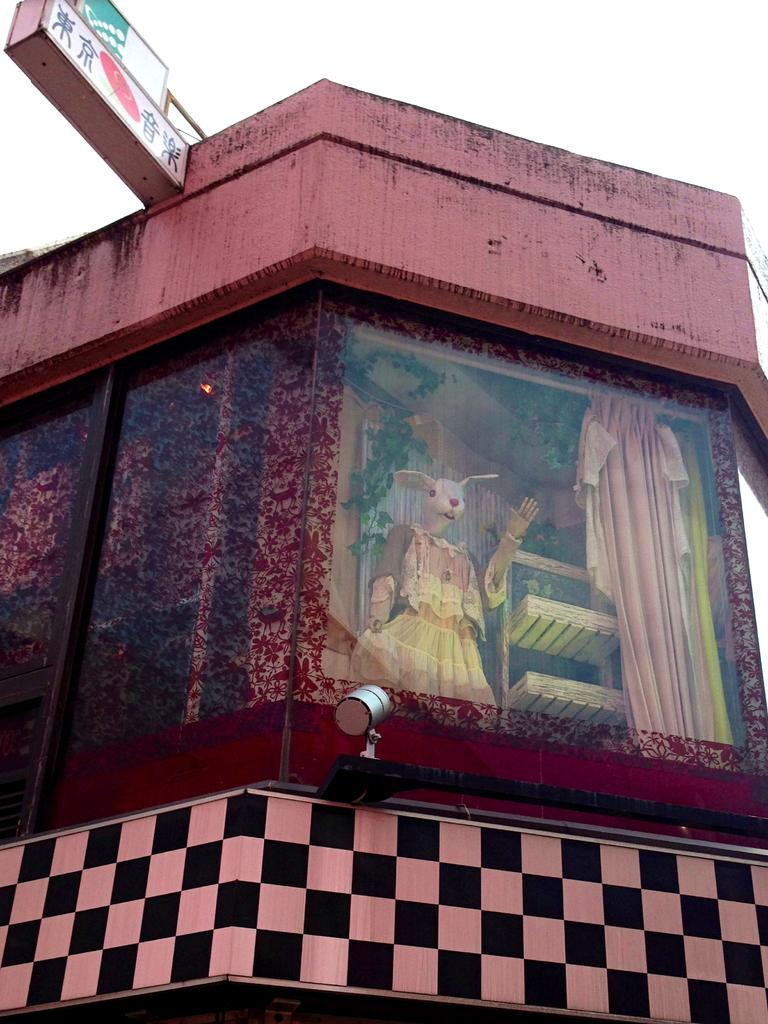What type of structure is present in the image? There is a building in the image. What figure can be seen in the image? There is a mannequin in the image. What object is present for displaying items? There is a stand in the image. What type of window treatment is visible in the image? There is a curtain visible through a glass door. What can be seen in the background of the image? The sky and a board are visible in the background of the image. How many clovers are growing on the board in the background of the image? There are no clovers visible on the board in the background of the image. What type of paper is being used by the mannequin in the image? The mannequin is not using any paper in the image. 